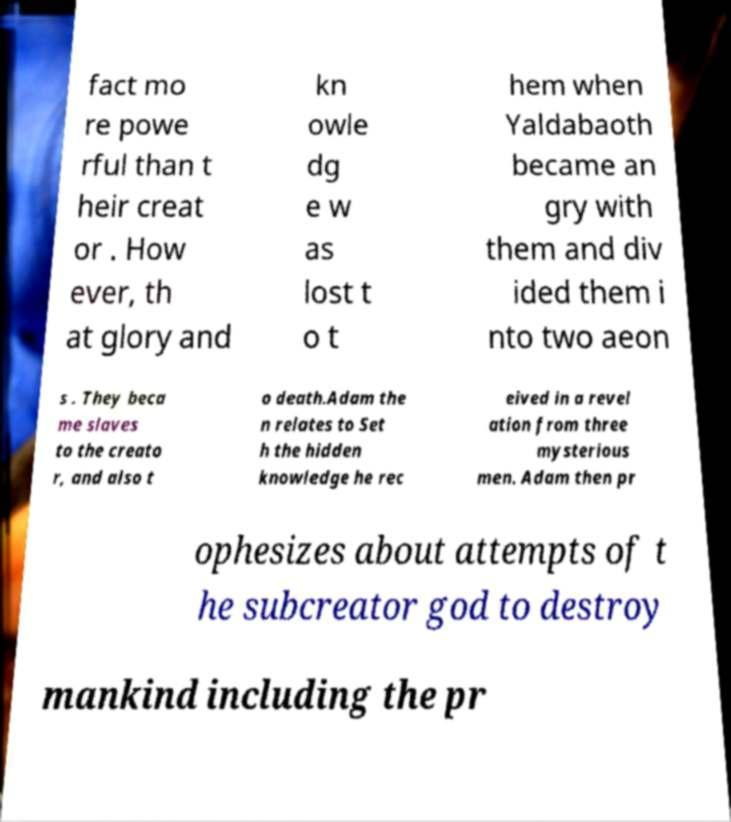Can you read and provide the text displayed in the image?This photo seems to have some interesting text. Can you extract and type it out for me? fact mo re powe rful than t heir creat or . How ever, th at glory and kn owle dg e w as lost t o t hem when Yaldabaoth became an gry with them and div ided them i nto two aeon s . They beca me slaves to the creato r, and also t o death.Adam the n relates to Set h the hidden knowledge he rec eived in a revel ation from three mysterious men. Adam then pr ophesizes about attempts of t he subcreator god to destroy mankind including the pr 